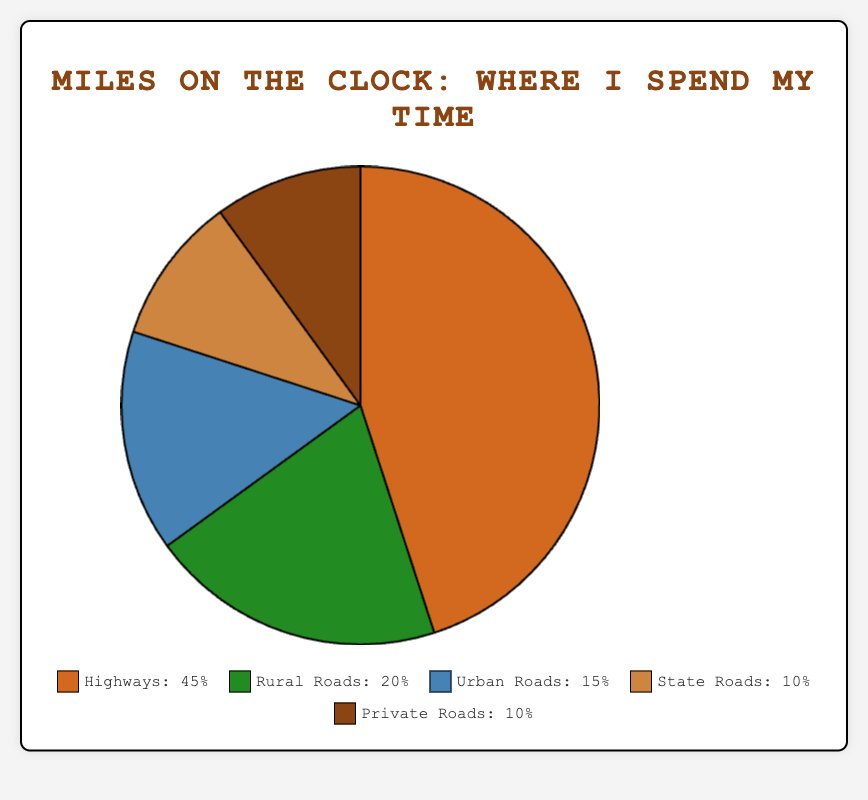Which type of road do you spend most of your driving time on? By looking at the pie chart, it's clear that the largest segment of the chart represents highways.
Answer: Highways Which types of roads do you spend equal time on? From the pie chart, the segments for state roads and private roads both represent 10% of the time spent, indicating they are equal.
Answer: State Roads and Private Roads What is the total time spent on Rural Roads and Urban Roads combined? According to the pie chart, Rural Roads account for 20% and Urban Roads for 15%. Adding these together gives 20% + 15% = 35%.
Answer: 35% What is the difference in time spent between Highways and State Roads? Highways account for 45% of the time, whereas State Roads account for 10%. The difference is 45% - 10% = 35%.
Answer: 35% What percentage of your time is spent on non-highway roads? Non-highway roads include Rural Roads (20%), Urban Roads (15%), State Roads (10%), and Private Roads (10%). Summing these gives 20% + 15% + 10% + 10% = 55%.
Answer: 55% How does the time spent on Urban Roads compare to that on Rural Roads? From the pie chart, Urban Roads account for 15% and Rural Roads account for 20%. Rural Roads have a higher percentage of time spent than Urban Roads.
Answer: Less than Rural Roads What color represents the time spent on State Roads in the pie chart? The pie chart uses different colors for each road type. The color for State Roads is brown.
Answer: Brown What is the average percentage time spent on State Roads and Private Roads? State Roads account for 10% and Private Roads also account for 10%. The average is (10% + 10%) / 2 = 10%.
Answer: 10% Which two road types combined nearly equal the time spent on Highways? The time spent on Highways is 45%. Rural Roads and Urban Roads together are 20% + 15% = 35%, and Private Roads and State Roads are 10% + 10% = 20%. Therefore, Rural Roads and Urban Roads combined nearly equal the time spent on Highways.
Answer: Rural Roads and Urban Roads How much more time is spent on Highways than on Private Roads? Based on the pie chart, Highways account for 45% and Private Roads for 10%. The additional time spent on Highways is 45% - 10% = 35%.
Answer: 35% 